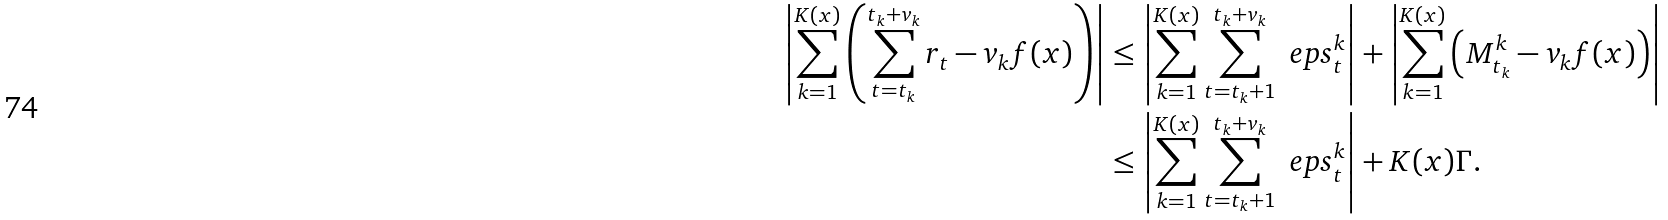Convert formula to latex. <formula><loc_0><loc_0><loc_500><loc_500>\left | \sum _ { k = 1 } ^ { K ( x ) } \left ( \sum _ { t = t _ { k } } ^ { t _ { k } + v _ { k } } r _ { t } - v _ { k } f ( x ) \right ) \right | & \leq \left | \sum _ { k = 1 } ^ { K ( x ) } \sum _ { t = t _ { k } + 1 } ^ { t _ { k } + v _ { k } } \ e p s _ { t } ^ { k } \right | + \left | \sum _ { k = 1 } ^ { K ( x ) } \left ( M _ { t _ { k } } ^ { k } - v _ { k } f ( x ) \right ) \right | \\ & \leq \left | \sum _ { k = 1 } ^ { K ( x ) } \sum _ { t = t _ { k } + 1 } ^ { t _ { k } + v _ { k } } \ e p s _ { t } ^ { k } \right | + K ( x ) \Gamma .</formula> 